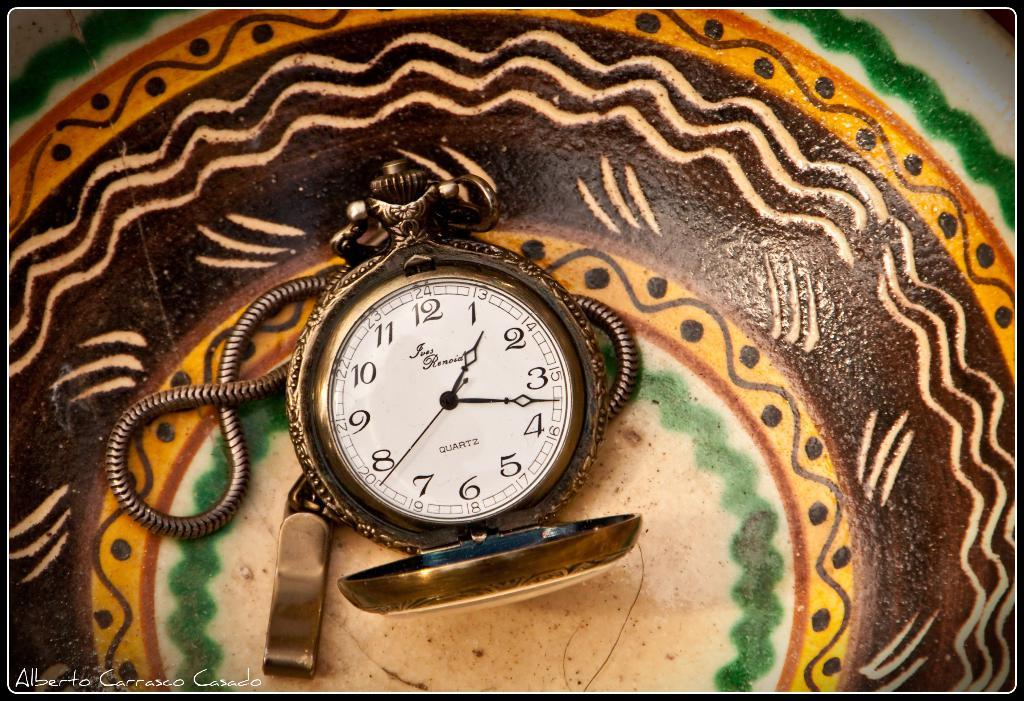<image>
Describe the image concisely. A decorative plate with a "Fues Renoia" pocket watch sitting on top of it. 